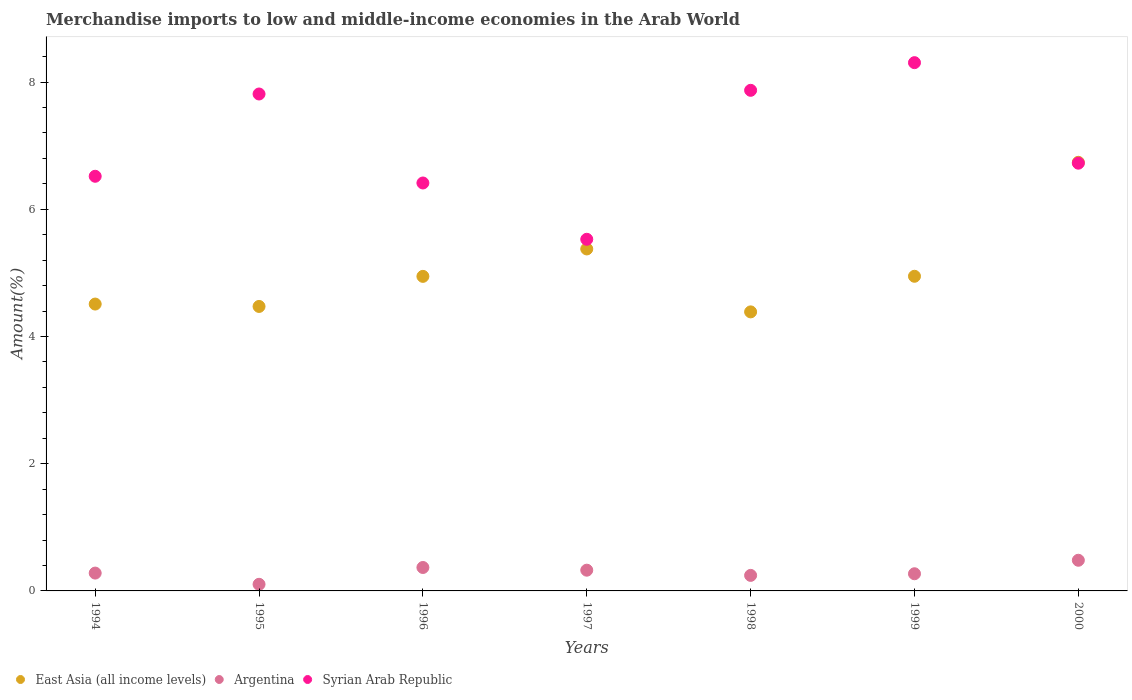How many different coloured dotlines are there?
Your response must be concise. 3. What is the percentage of amount earned from merchandise imports in East Asia (all income levels) in 1995?
Provide a short and direct response. 4.47. Across all years, what is the maximum percentage of amount earned from merchandise imports in East Asia (all income levels)?
Your response must be concise. 6.74. Across all years, what is the minimum percentage of amount earned from merchandise imports in Syrian Arab Republic?
Your response must be concise. 5.53. In which year was the percentage of amount earned from merchandise imports in East Asia (all income levels) maximum?
Provide a short and direct response. 2000. What is the total percentage of amount earned from merchandise imports in Syrian Arab Republic in the graph?
Ensure brevity in your answer.  49.17. What is the difference between the percentage of amount earned from merchandise imports in East Asia (all income levels) in 1997 and that in 2000?
Offer a very short reply. -1.36. What is the difference between the percentage of amount earned from merchandise imports in East Asia (all income levels) in 1995 and the percentage of amount earned from merchandise imports in Syrian Arab Republic in 1999?
Ensure brevity in your answer.  -3.83. What is the average percentage of amount earned from merchandise imports in Argentina per year?
Make the answer very short. 0.3. In the year 1994, what is the difference between the percentage of amount earned from merchandise imports in East Asia (all income levels) and percentage of amount earned from merchandise imports in Syrian Arab Republic?
Provide a succinct answer. -2.01. In how many years, is the percentage of amount earned from merchandise imports in Syrian Arab Republic greater than 2.4 %?
Keep it short and to the point. 7. What is the ratio of the percentage of amount earned from merchandise imports in Argentina in 1995 to that in 2000?
Your answer should be compact. 0.22. What is the difference between the highest and the second highest percentage of amount earned from merchandise imports in East Asia (all income levels)?
Your answer should be compact. 1.36. What is the difference between the highest and the lowest percentage of amount earned from merchandise imports in Syrian Arab Republic?
Your response must be concise. 2.78. In how many years, is the percentage of amount earned from merchandise imports in Syrian Arab Republic greater than the average percentage of amount earned from merchandise imports in Syrian Arab Republic taken over all years?
Give a very brief answer. 3. Is it the case that in every year, the sum of the percentage of amount earned from merchandise imports in East Asia (all income levels) and percentage of amount earned from merchandise imports in Syrian Arab Republic  is greater than the percentage of amount earned from merchandise imports in Argentina?
Make the answer very short. Yes. Does the percentage of amount earned from merchandise imports in Syrian Arab Republic monotonically increase over the years?
Your answer should be compact. No. Is the percentage of amount earned from merchandise imports in Argentina strictly greater than the percentage of amount earned from merchandise imports in East Asia (all income levels) over the years?
Your answer should be very brief. No. How many years are there in the graph?
Keep it short and to the point. 7. What is the difference between two consecutive major ticks on the Y-axis?
Offer a very short reply. 2. Are the values on the major ticks of Y-axis written in scientific E-notation?
Ensure brevity in your answer.  No. Does the graph contain grids?
Provide a succinct answer. No. Where does the legend appear in the graph?
Your response must be concise. Bottom left. How many legend labels are there?
Ensure brevity in your answer.  3. What is the title of the graph?
Provide a succinct answer. Merchandise imports to low and middle-income economies in the Arab World. Does "Estonia" appear as one of the legend labels in the graph?
Provide a short and direct response. No. What is the label or title of the Y-axis?
Offer a terse response. Amount(%). What is the Amount(%) of East Asia (all income levels) in 1994?
Ensure brevity in your answer.  4.51. What is the Amount(%) in Argentina in 1994?
Ensure brevity in your answer.  0.28. What is the Amount(%) in Syrian Arab Republic in 1994?
Provide a short and direct response. 6.52. What is the Amount(%) in East Asia (all income levels) in 1995?
Provide a succinct answer. 4.47. What is the Amount(%) of Argentina in 1995?
Ensure brevity in your answer.  0.1. What is the Amount(%) in Syrian Arab Republic in 1995?
Your answer should be compact. 7.81. What is the Amount(%) of East Asia (all income levels) in 1996?
Your answer should be compact. 4.95. What is the Amount(%) in Argentina in 1996?
Provide a short and direct response. 0.37. What is the Amount(%) in Syrian Arab Republic in 1996?
Provide a short and direct response. 6.41. What is the Amount(%) in East Asia (all income levels) in 1997?
Give a very brief answer. 5.38. What is the Amount(%) in Argentina in 1997?
Ensure brevity in your answer.  0.33. What is the Amount(%) of Syrian Arab Republic in 1997?
Keep it short and to the point. 5.53. What is the Amount(%) in East Asia (all income levels) in 1998?
Your answer should be compact. 4.39. What is the Amount(%) in Argentina in 1998?
Make the answer very short. 0.24. What is the Amount(%) in Syrian Arab Republic in 1998?
Your answer should be very brief. 7.87. What is the Amount(%) of East Asia (all income levels) in 1999?
Provide a succinct answer. 4.95. What is the Amount(%) in Argentina in 1999?
Give a very brief answer. 0.27. What is the Amount(%) of Syrian Arab Republic in 1999?
Your answer should be very brief. 8.3. What is the Amount(%) in East Asia (all income levels) in 2000?
Offer a very short reply. 6.74. What is the Amount(%) in Argentina in 2000?
Provide a short and direct response. 0.48. What is the Amount(%) in Syrian Arab Republic in 2000?
Provide a succinct answer. 6.72. Across all years, what is the maximum Amount(%) of East Asia (all income levels)?
Offer a very short reply. 6.74. Across all years, what is the maximum Amount(%) of Argentina?
Your answer should be compact. 0.48. Across all years, what is the maximum Amount(%) of Syrian Arab Republic?
Keep it short and to the point. 8.3. Across all years, what is the minimum Amount(%) in East Asia (all income levels)?
Provide a short and direct response. 4.39. Across all years, what is the minimum Amount(%) of Argentina?
Offer a very short reply. 0.1. Across all years, what is the minimum Amount(%) of Syrian Arab Republic?
Make the answer very short. 5.53. What is the total Amount(%) in East Asia (all income levels) in the graph?
Your answer should be compact. 35.37. What is the total Amount(%) in Argentina in the graph?
Offer a very short reply. 2.07. What is the total Amount(%) of Syrian Arab Republic in the graph?
Keep it short and to the point. 49.17. What is the difference between the Amount(%) in East Asia (all income levels) in 1994 and that in 1995?
Your answer should be very brief. 0.04. What is the difference between the Amount(%) in Argentina in 1994 and that in 1995?
Your response must be concise. 0.18. What is the difference between the Amount(%) of Syrian Arab Republic in 1994 and that in 1995?
Your response must be concise. -1.29. What is the difference between the Amount(%) in East Asia (all income levels) in 1994 and that in 1996?
Offer a very short reply. -0.44. What is the difference between the Amount(%) of Argentina in 1994 and that in 1996?
Provide a succinct answer. -0.09. What is the difference between the Amount(%) of Syrian Arab Republic in 1994 and that in 1996?
Give a very brief answer. 0.11. What is the difference between the Amount(%) in East Asia (all income levels) in 1994 and that in 1997?
Your answer should be very brief. -0.87. What is the difference between the Amount(%) in Argentina in 1994 and that in 1997?
Your response must be concise. -0.05. What is the difference between the Amount(%) of Syrian Arab Republic in 1994 and that in 1997?
Offer a very short reply. 0.99. What is the difference between the Amount(%) in East Asia (all income levels) in 1994 and that in 1998?
Give a very brief answer. 0.12. What is the difference between the Amount(%) in Argentina in 1994 and that in 1998?
Provide a short and direct response. 0.04. What is the difference between the Amount(%) of Syrian Arab Republic in 1994 and that in 1998?
Provide a succinct answer. -1.35. What is the difference between the Amount(%) in East Asia (all income levels) in 1994 and that in 1999?
Offer a very short reply. -0.44. What is the difference between the Amount(%) in Argentina in 1994 and that in 1999?
Provide a short and direct response. 0.01. What is the difference between the Amount(%) of Syrian Arab Republic in 1994 and that in 1999?
Offer a very short reply. -1.79. What is the difference between the Amount(%) of East Asia (all income levels) in 1994 and that in 2000?
Ensure brevity in your answer.  -2.23. What is the difference between the Amount(%) of Argentina in 1994 and that in 2000?
Provide a short and direct response. -0.2. What is the difference between the Amount(%) in Syrian Arab Republic in 1994 and that in 2000?
Give a very brief answer. -0.21. What is the difference between the Amount(%) in East Asia (all income levels) in 1995 and that in 1996?
Provide a short and direct response. -0.47. What is the difference between the Amount(%) of Argentina in 1995 and that in 1996?
Provide a short and direct response. -0.26. What is the difference between the Amount(%) in Syrian Arab Republic in 1995 and that in 1996?
Your response must be concise. 1.4. What is the difference between the Amount(%) of East Asia (all income levels) in 1995 and that in 1997?
Offer a terse response. -0.9. What is the difference between the Amount(%) in Argentina in 1995 and that in 1997?
Provide a short and direct response. -0.22. What is the difference between the Amount(%) of Syrian Arab Republic in 1995 and that in 1997?
Offer a terse response. 2.28. What is the difference between the Amount(%) in East Asia (all income levels) in 1995 and that in 1998?
Provide a succinct answer. 0.09. What is the difference between the Amount(%) in Argentina in 1995 and that in 1998?
Provide a short and direct response. -0.14. What is the difference between the Amount(%) of Syrian Arab Republic in 1995 and that in 1998?
Offer a very short reply. -0.06. What is the difference between the Amount(%) of East Asia (all income levels) in 1995 and that in 1999?
Offer a terse response. -0.47. What is the difference between the Amount(%) of Argentina in 1995 and that in 1999?
Provide a short and direct response. -0.17. What is the difference between the Amount(%) of Syrian Arab Republic in 1995 and that in 1999?
Make the answer very short. -0.49. What is the difference between the Amount(%) in East Asia (all income levels) in 1995 and that in 2000?
Offer a terse response. -2.27. What is the difference between the Amount(%) in Argentina in 1995 and that in 2000?
Provide a short and direct response. -0.38. What is the difference between the Amount(%) in Syrian Arab Republic in 1995 and that in 2000?
Make the answer very short. 1.09. What is the difference between the Amount(%) in East Asia (all income levels) in 1996 and that in 1997?
Make the answer very short. -0.43. What is the difference between the Amount(%) of Argentina in 1996 and that in 1997?
Provide a short and direct response. 0.04. What is the difference between the Amount(%) in Syrian Arab Republic in 1996 and that in 1997?
Keep it short and to the point. 0.89. What is the difference between the Amount(%) of East Asia (all income levels) in 1996 and that in 1998?
Make the answer very short. 0.56. What is the difference between the Amount(%) of Argentina in 1996 and that in 1998?
Keep it short and to the point. 0.12. What is the difference between the Amount(%) in Syrian Arab Republic in 1996 and that in 1998?
Provide a succinct answer. -1.46. What is the difference between the Amount(%) in East Asia (all income levels) in 1996 and that in 1999?
Make the answer very short. -0. What is the difference between the Amount(%) in Argentina in 1996 and that in 1999?
Offer a terse response. 0.1. What is the difference between the Amount(%) of Syrian Arab Republic in 1996 and that in 1999?
Your answer should be compact. -1.89. What is the difference between the Amount(%) of East Asia (all income levels) in 1996 and that in 2000?
Keep it short and to the point. -1.79. What is the difference between the Amount(%) in Argentina in 1996 and that in 2000?
Keep it short and to the point. -0.11. What is the difference between the Amount(%) in Syrian Arab Republic in 1996 and that in 2000?
Your answer should be compact. -0.31. What is the difference between the Amount(%) of Argentina in 1997 and that in 1998?
Make the answer very short. 0.08. What is the difference between the Amount(%) of Syrian Arab Republic in 1997 and that in 1998?
Offer a terse response. -2.34. What is the difference between the Amount(%) in East Asia (all income levels) in 1997 and that in 1999?
Keep it short and to the point. 0.43. What is the difference between the Amount(%) in Argentina in 1997 and that in 1999?
Ensure brevity in your answer.  0.06. What is the difference between the Amount(%) in Syrian Arab Republic in 1997 and that in 1999?
Offer a very short reply. -2.78. What is the difference between the Amount(%) in East Asia (all income levels) in 1997 and that in 2000?
Make the answer very short. -1.36. What is the difference between the Amount(%) in Argentina in 1997 and that in 2000?
Your answer should be compact. -0.16. What is the difference between the Amount(%) in Syrian Arab Republic in 1997 and that in 2000?
Offer a terse response. -1.2. What is the difference between the Amount(%) in East Asia (all income levels) in 1998 and that in 1999?
Provide a succinct answer. -0.56. What is the difference between the Amount(%) of Argentina in 1998 and that in 1999?
Offer a terse response. -0.03. What is the difference between the Amount(%) of Syrian Arab Republic in 1998 and that in 1999?
Provide a short and direct response. -0.43. What is the difference between the Amount(%) of East Asia (all income levels) in 1998 and that in 2000?
Keep it short and to the point. -2.35. What is the difference between the Amount(%) of Argentina in 1998 and that in 2000?
Keep it short and to the point. -0.24. What is the difference between the Amount(%) of Syrian Arab Republic in 1998 and that in 2000?
Your answer should be very brief. 1.15. What is the difference between the Amount(%) of East Asia (all income levels) in 1999 and that in 2000?
Your response must be concise. -1.79. What is the difference between the Amount(%) of Argentina in 1999 and that in 2000?
Offer a terse response. -0.21. What is the difference between the Amount(%) of Syrian Arab Republic in 1999 and that in 2000?
Keep it short and to the point. 1.58. What is the difference between the Amount(%) of East Asia (all income levels) in 1994 and the Amount(%) of Argentina in 1995?
Give a very brief answer. 4.41. What is the difference between the Amount(%) of East Asia (all income levels) in 1994 and the Amount(%) of Syrian Arab Republic in 1995?
Offer a terse response. -3.3. What is the difference between the Amount(%) of Argentina in 1994 and the Amount(%) of Syrian Arab Republic in 1995?
Your response must be concise. -7.53. What is the difference between the Amount(%) of East Asia (all income levels) in 1994 and the Amount(%) of Argentina in 1996?
Your answer should be very brief. 4.14. What is the difference between the Amount(%) of East Asia (all income levels) in 1994 and the Amount(%) of Syrian Arab Republic in 1996?
Give a very brief answer. -1.9. What is the difference between the Amount(%) in Argentina in 1994 and the Amount(%) in Syrian Arab Republic in 1996?
Your answer should be compact. -6.13. What is the difference between the Amount(%) in East Asia (all income levels) in 1994 and the Amount(%) in Argentina in 1997?
Give a very brief answer. 4.18. What is the difference between the Amount(%) in East Asia (all income levels) in 1994 and the Amount(%) in Syrian Arab Republic in 1997?
Your answer should be very brief. -1.02. What is the difference between the Amount(%) in Argentina in 1994 and the Amount(%) in Syrian Arab Republic in 1997?
Offer a terse response. -5.25. What is the difference between the Amount(%) of East Asia (all income levels) in 1994 and the Amount(%) of Argentina in 1998?
Offer a very short reply. 4.27. What is the difference between the Amount(%) of East Asia (all income levels) in 1994 and the Amount(%) of Syrian Arab Republic in 1998?
Offer a very short reply. -3.36. What is the difference between the Amount(%) of Argentina in 1994 and the Amount(%) of Syrian Arab Republic in 1998?
Keep it short and to the point. -7.59. What is the difference between the Amount(%) of East Asia (all income levels) in 1994 and the Amount(%) of Argentina in 1999?
Give a very brief answer. 4.24. What is the difference between the Amount(%) in East Asia (all income levels) in 1994 and the Amount(%) in Syrian Arab Republic in 1999?
Your response must be concise. -3.79. What is the difference between the Amount(%) of Argentina in 1994 and the Amount(%) of Syrian Arab Republic in 1999?
Provide a short and direct response. -8.02. What is the difference between the Amount(%) in East Asia (all income levels) in 1994 and the Amount(%) in Argentina in 2000?
Give a very brief answer. 4.03. What is the difference between the Amount(%) of East Asia (all income levels) in 1994 and the Amount(%) of Syrian Arab Republic in 2000?
Your response must be concise. -2.21. What is the difference between the Amount(%) in Argentina in 1994 and the Amount(%) in Syrian Arab Republic in 2000?
Your response must be concise. -6.44. What is the difference between the Amount(%) of East Asia (all income levels) in 1995 and the Amount(%) of Argentina in 1996?
Offer a terse response. 4.1. What is the difference between the Amount(%) in East Asia (all income levels) in 1995 and the Amount(%) in Syrian Arab Republic in 1996?
Give a very brief answer. -1.94. What is the difference between the Amount(%) in Argentina in 1995 and the Amount(%) in Syrian Arab Republic in 1996?
Keep it short and to the point. -6.31. What is the difference between the Amount(%) of East Asia (all income levels) in 1995 and the Amount(%) of Argentina in 1997?
Your answer should be very brief. 4.15. What is the difference between the Amount(%) of East Asia (all income levels) in 1995 and the Amount(%) of Syrian Arab Republic in 1997?
Give a very brief answer. -1.06. What is the difference between the Amount(%) of Argentina in 1995 and the Amount(%) of Syrian Arab Republic in 1997?
Ensure brevity in your answer.  -5.42. What is the difference between the Amount(%) of East Asia (all income levels) in 1995 and the Amount(%) of Argentina in 1998?
Your answer should be compact. 4.23. What is the difference between the Amount(%) of East Asia (all income levels) in 1995 and the Amount(%) of Syrian Arab Republic in 1998?
Your answer should be very brief. -3.4. What is the difference between the Amount(%) in Argentina in 1995 and the Amount(%) in Syrian Arab Republic in 1998?
Your response must be concise. -7.77. What is the difference between the Amount(%) in East Asia (all income levels) in 1995 and the Amount(%) in Argentina in 1999?
Your response must be concise. 4.2. What is the difference between the Amount(%) in East Asia (all income levels) in 1995 and the Amount(%) in Syrian Arab Republic in 1999?
Keep it short and to the point. -3.83. What is the difference between the Amount(%) of Argentina in 1995 and the Amount(%) of Syrian Arab Republic in 1999?
Offer a very short reply. -8.2. What is the difference between the Amount(%) in East Asia (all income levels) in 1995 and the Amount(%) in Argentina in 2000?
Your response must be concise. 3.99. What is the difference between the Amount(%) in East Asia (all income levels) in 1995 and the Amount(%) in Syrian Arab Republic in 2000?
Ensure brevity in your answer.  -2.25. What is the difference between the Amount(%) of Argentina in 1995 and the Amount(%) of Syrian Arab Republic in 2000?
Your answer should be compact. -6.62. What is the difference between the Amount(%) in East Asia (all income levels) in 1996 and the Amount(%) in Argentina in 1997?
Your answer should be compact. 4.62. What is the difference between the Amount(%) of East Asia (all income levels) in 1996 and the Amount(%) of Syrian Arab Republic in 1997?
Make the answer very short. -0.58. What is the difference between the Amount(%) in Argentina in 1996 and the Amount(%) in Syrian Arab Republic in 1997?
Your answer should be compact. -5.16. What is the difference between the Amount(%) in East Asia (all income levels) in 1996 and the Amount(%) in Argentina in 1998?
Offer a terse response. 4.7. What is the difference between the Amount(%) in East Asia (all income levels) in 1996 and the Amount(%) in Syrian Arab Republic in 1998?
Give a very brief answer. -2.92. What is the difference between the Amount(%) in Argentina in 1996 and the Amount(%) in Syrian Arab Republic in 1998?
Provide a succinct answer. -7.5. What is the difference between the Amount(%) in East Asia (all income levels) in 1996 and the Amount(%) in Argentina in 1999?
Offer a very short reply. 4.68. What is the difference between the Amount(%) in East Asia (all income levels) in 1996 and the Amount(%) in Syrian Arab Republic in 1999?
Offer a terse response. -3.36. What is the difference between the Amount(%) in Argentina in 1996 and the Amount(%) in Syrian Arab Republic in 1999?
Make the answer very short. -7.94. What is the difference between the Amount(%) in East Asia (all income levels) in 1996 and the Amount(%) in Argentina in 2000?
Offer a very short reply. 4.46. What is the difference between the Amount(%) of East Asia (all income levels) in 1996 and the Amount(%) of Syrian Arab Republic in 2000?
Keep it short and to the point. -1.78. What is the difference between the Amount(%) of Argentina in 1996 and the Amount(%) of Syrian Arab Republic in 2000?
Offer a terse response. -6.36. What is the difference between the Amount(%) in East Asia (all income levels) in 1997 and the Amount(%) in Argentina in 1998?
Keep it short and to the point. 5.13. What is the difference between the Amount(%) in East Asia (all income levels) in 1997 and the Amount(%) in Syrian Arab Republic in 1998?
Ensure brevity in your answer.  -2.49. What is the difference between the Amount(%) of Argentina in 1997 and the Amount(%) of Syrian Arab Republic in 1998?
Offer a very short reply. -7.54. What is the difference between the Amount(%) in East Asia (all income levels) in 1997 and the Amount(%) in Argentina in 1999?
Provide a short and direct response. 5.11. What is the difference between the Amount(%) of East Asia (all income levels) in 1997 and the Amount(%) of Syrian Arab Republic in 1999?
Ensure brevity in your answer.  -2.93. What is the difference between the Amount(%) of Argentina in 1997 and the Amount(%) of Syrian Arab Republic in 1999?
Make the answer very short. -7.98. What is the difference between the Amount(%) of East Asia (all income levels) in 1997 and the Amount(%) of Argentina in 2000?
Offer a terse response. 4.89. What is the difference between the Amount(%) in East Asia (all income levels) in 1997 and the Amount(%) in Syrian Arab Republic in 2000?
Make the answer very short. -1.35. What is the difference between the Amount(%) of Argentina in 1997 and the Amount(%) of Syrian Arab Republic in 2000?
Give a very brief answer. -6.4. What is the difference between the Amount(%) of East Asia (all income levels) in 1998 and the Amount(%) of Argentina in 1999?
Your answer should be very brief. 4.12. What is the difference between the Amount(%) in East Asia (all income levels) in 1998 and the Amount(%) in Syrian Arab Republic in 1999?
Your response must be concise. -3.92. What is the difference between the Amount(%) in Argentina in 1998 and the Amount(%) in Syrian Arab Republic in 1999?
Provide a succinct answer. -8.06. What is the difference between the Amount(%) in East Asia (all income levels) in 1998 and the Amount(%) in Argentina in 2000?
Keep it short and to the point. 3.9. What is the difference between the Amount(%) in East Asia (all income levels) in 1998 and the Amount(%) in Syrian Arab Republic in 2000?
Offer a terse response. -2.34. What is the difference between the Amount(%) in Argentina in 1998 and the Amount(%) in Syrian Arab Republic in 2000?
Your response must be concise. -6.48. What is the difference between the Amount(%) in East Asia (all income levels) in 1999 and the Amount(%) in Argentina in 2000?
Your answer should be very brief. 4.46. What is the difference between the Amount(%) of East Asia (all income levels) in 1999 and the Amount(%) of Syrian Arab Republic in 2000?
Keep it short and to the point. -1.78. What is the difference between the Amount(%) of Argentina in 1999 and the Amount(%) of Syrian Arab Republic in 2000?
Make the answer very short. -6.45. What is the average Amount(%) of East Asia (all income levels) per year?
Make the answer very short. 5.05. What is the average Amount(%) in Argentina per year?
Ensure brevity in your answer.  0.3. What is the average Amount(%) in Syrian Arab Republic per year?
Make the answer very short. 7.02. In the year 1994, what is the difference between the Amount(%) of East Asia (all income levels) and Amount(%) of Argentina?
Offer a very short reply. 4.23. In the year 1994, what is the difference between the Amount(%) in East Asia (all income levels) and Amount(%) in Syrian Arab Republic?
Keep it short and to the point. -2.01. In the year 1994, what is the difference between the Amount(%) of Argentina and Amount(%) of Syrian Arab Republic?
Give a very brief answer. -6.24. In the year 1995, what is the difference between the Amount(%) in East Asia (all income levels) and Amount(%) in Argentina?
Your response must be concise. 4.37. In the year 1995, what is the difference between the Amount(%) of East Asia (all income levels) and Amount(%) of Syrian Arab Republic?
Offer a terse response. -3.34. In the year 1995, what is the difference between the Amount(%) in Argentina and Amount(%) in Syrian Arab Republic?
Provide a short and direct response. -7.71. In the year 1996, what is the difference between the Amount(%) of East Asia (all income levels) and Amount(%) of Argentina?
Provide a succinct answer. 4.58. In the year 1996, what is the difference between the Amount(%) in East Asia (all income levels) and Amount(%) in Syrian Arab Republic?
Give a very brief answer. -1.47. In the year 1996, what is the difference between the Amount(%) of Argentina and Amount(%) of Syrian Arab Republic?
Your response must be concise. -6.04. In the year 1997, what is the difference between the Amount(%) in East Asia (all income levels) and Amount(%) in Argentina?
Your response must be concise. 5.05. In the year 1997, what is the difference between the Amount(%) in East Asia (all income levels) and Amount(%) in Syrian Arab Republic?
Provide a succinct answer. -0.15. In the year 1997, what is the difference between the Amount(%) of Argentina and Amount(%) of Syrian Arab Republic?
Provide a short and direct response. -5.2. In the year 1998, what is the difference between the Amount(%) in East Asia (all income levels) and Amount(%) in Argentina?
Offer a very short reply. 4.14. In the year 1998, what is the difference between the Amount(%) of East Asia (all income levels) and Amount(%) of Syrian Arab Republic?
Your answer should be very brief. -3.48. In the year 1998, what is the difference between the Amount(%) in Argentina and Amount(%) in Syrian Arab Republic?
Your response must be concise. -7.63. In the year 1999, what is the difference between the Amount(%) in East Asia (all income levels) and Amount(%) in Argentina?
Keep it short and to the point. 4.68. In the year 1999, what is the difference between the Amount(%) in East Asia (all income levels) and Amount(%) in Syrian Arab Republic?
Ensure brevity in your answer.  -3.36. In the year 1999, what is the difference between the Amount(%) in Argentina and Amount(%) in Syrian Arab Republic?
Ensure brevity in your answer.  -8.03. In the year 2000, what is the difference between the Amount(%) of East Asia (all income levels) and Amount(%) of Argentina?
Provide a short and direct response. 6.26. In the year 2000, what is the difference between the Amount(%) of East Asia (all income levels) and Amount(%) of Syrian Arab Republic?
Offer a very short reply. 0.01. In the year 2000, what is the difference between the Amount(%) of Argentina and Amount(%) of Syrian Arab Republic?
Give a very brief answer. -6.24. What is the ratio of the Amount(%) in East Asia (all income levels) in 1994 to that in 1995?
Give a very brief answer. 1.01. What is the ratio of the Amount(%) in Argentina in 1994 to that in 1995?
Make the answer very short. 2.69. What is the ratio of the Amount(%) in Syrian Arab Republic in 1994 to that in 1995?
Make the answer very short. 0.83. What is the ratio of the Amount(%) in East Asia (all income levels) in 1994 to that in 1996?
Your answer should be compact. 0.91. What is the ratio of the Amount(%) in Argentina in 1994 to that in 1996?
Provide a short and direct response. 0.76. What is the ratio of the Amount(%) in Syrian Arab Republic in 1994 to that in 1996?
Provide a succinct answer. 1.02. What is the ratio of the Amount(%) of East Asia (all income levels) in 1994 to that in 1997?
Offer a very short reply. 0.84. What is the ratio of the Amount(%) in Argentina in 1994 to that in 1997?
Ensure brevity in your answer.  0.86. What is the ratio of the Amount(%) in Syrian Arab Republic in 1994 to that in 1997?
Your answer should be compact. 1.18. What is the ratio of the Amount(%) of East Asia (all income levels) in 1994 to that in 1998?
Your answer should be compact. 1.03. What is the ratio of the Amount(%) of Argentina in 1994 to that in 1998?
Keep it short and to the point. 1.15. What is the ratio of the Amount(%) in Syrian Arab Republic in 1994 to that in 1998?
Make the answer very short. 0.83. What is the ratio of the Amount(%) of East Asia (all income levels) in 1994 to that in 1999?
Your response must be concise. 0.91. What is the ratio of the Amount(%) of Argentina in 1994 to that in 1999?
Offer a very short reply. 1.04. What is the ratio of the Amount(%) of Syrian Arab Republic in 1994 to that in 1999?
Offer a very short reply. 0.78. What is the ratio of the Amount(%) in East Asia (all income levels) in 1994 to that in 2000?
Keep it short and to the point. 0.67. What is the ratio of the Amount(%) of Argentina in 1994 to that in 2000?
Your response must be concise. 0.58. What is the ratio of the Amount(%) in Syrian Arab Republic in 1994 to that in 2000?
Keep it short and to the point. 0.97. What is the ratio of the Amount(%) of East Asia (all income levels) in 1995 to that in 1996?
Make the answer very short. 0.9. What is the ratio of the Amount(%) of Argentina in 1995 to that in 1996?
Your answer should be very brief. 0.28. What is the ratio of the Amount(%) of Syrian Arab Republic in 1995 to that in 1996?
Ensure brevity in your answer.  1.22. What is the ratio of the Amount(%) in East Asia (all income levels) in 1995 to that in 1997?
Your response must be concise. 0.83. What is the ratio of the Amount(%) in Argentina in 1995 to that in 1997?
Your response must be concise. 0.32. What is the ratio of the Amount(%) of Syrian Arab Republic in 1995 to that in 1997?
Ensure brevity in your answer.  1.41. What is the ratio of the Amount(%) of East Asia (all income levels) in 1995 to that in 1998?
Provide a short and direct response. 1.02. What is the ratio of the Amount(%) in Argentina in 1995 to that in 1998?
Keep it short and to the point. 0.43. What is the ratio of the Amount(%) in Syrian Arab Republic in 1995 to that in 1998?
Provide a succinct answer. 0.99. What is the ratio of the Amount(%) of East Asia (all income levels) in 1995 to that in 1999?
Your answer should be very brief. 0.9. What is the ratio of the Amount(%) of Argentina in 1995 to that in 1999?
Offer a very short reply. 0.39. What is the ratio of the Amount(%) of Syrian Arab Republic in 1995 to that in 1999?
Provide a short and direct response. 0.94. What is the ratio of the Amount(%) of East Asia (all income levels) in 1995 to that in 2000?
Provide a succinct answer. 0.66. What is the ratio of the Amount(%) in Argentina in 1995 to that in 2000?
Provide a short and direct response. 0.22. What is the ratio of the Amount(%) in Syrian Arab Republic in 1995 to that in 2000?
Make the answer very short. 1.16. What is the ratio of the Amount(%) of East Asia (all income levels) in 1996 to that in 1997?
Provide a short and direct response. 0.92. What is the ratio of the Amount(%) of Argentina in 1996 to that in 1997?
Your response must be concise. 1.13. What is the ratio of the Amount(%) of Syrian Arab Republic in 1996 to that in 1997?
Give a very brief answer. 1.16. What is the ratio of the Amount(%) in East Asia (all income levels) in 1996 to that in 1998?
Your response must be concise. 1.13. What is the ratio of the Amount(%) of Argentina in 1996 to that in 1998?
Give a very brief answer. 1.51. What is the ratio of the Amount(%) in Syrian Arab Republic in 1996 to that in 1998?
Your answer should be compact. 0.81. What is the ratio of the Amount(%) in East Asia (all income levels) in 1996 to that in 1999?
Make the answer very short. 1. What is the ratio of the Amount(%) of Argentina in 1996 to that in 1999?
Keep it short and to the point. 1.37. What is the ratio of the Amount(%) of Syrian Arab Republic in 1996 to that in 1999?
Your answer should be compact. 0.77. What is the ratio of the Amount(%) of East Asia (all income levels) in 1996 to that in 2000?
Ensure brevity in your answer.  0.73. What is the ratio of the Amount(%) of Argentina in 1996 to that in 2000?
Give a very brief answer. 0.76. What is the ratio of the Amount(%) in Syrian Arab Republic in 1996 to that in 2000?
Offer a terse response. 0.95. What is the ratio of the Amount(%) in East Asia (all income levels) in 1997 to that in 1998?
Provide a succinct answer. 1.23. What is the ratio of the Amount(%) in Argentina in 1997 to that in 1998?
Your response must be concise. 1.33. What is the ratio of the Amount(%) of Syrian Arab Republic in 1997 to that in 1998?
Your answer should be very brief. 0.7. What is the ratio of the Amount(%) of East Asia (all income levels) in 1997 to that in 1999?
Your answer should be very brief. 1.09. What is the ratio of the Amount(%) of Argentina in 1997 to that in 1999?
Provide a succinct answer. 1.21. What is the ratio of the Amount(%) in Syrian Arab Republic in 1997 to that in 1999?
Your answer should be very brief. 0.67. What is the ratio of the Amount(%) in East Asia (all income levels) in 1997 to that in 2000?
Your answer should be compact. 0.8. What is the ratio of the Amount(%) in Argentina in 1997 to that in 2000?
Offer a terse response. 0.68. What is the ratio of the Amount(%) in Syrian Arab Republic in 1997 to that in 2000?
Your answer should be compact. 0.82. What is the ratio of the Amount(%) of East Asia (all income levels) in 1998 to that in 1999?
Keep it short and to the point. 0.89. What is the ratio of the Amount(%) in Argentina in 1998 to that in 1999?
Your response must be concise. 0.9. What is the ratio of the Amount(%) in Syrian Arab Republic in 1998 to that in 1999?
Your answer should be very brief. 0.95. What is the ratio of the Amount(%) in East Asia (all income levels) in 1998 to that in 2000?
Ensure brevity in your answer.  0.65. What is the ratio of the Amount(%) in Argentina in 1998 to that in 2000?
Give a very brief answer. 0.51. What is the ratio of the Amount(%) of Syrian Arab Republic in 1998 to that in 2000?
Make the answer very short. 1.17. What is the ratio of the Amount(%) in East Asia (all income levels) in 1999 to that in 2000?
Make the answer very short. 0.73. What is the ratio of the Amount(%) of Argentina in 1999 to that in 2000?
Offer a terse response. 0.56. What is the ratio of the Amount(%) in Syrian Arab Republic in 1999 to that in 2000?
Your answer should be very brief. 1.24. What is the difference between the highest and the second highest Amount(%) in East Asia (all income levels)?
Provide a succinct answer. 1.36. What is the difference between the highest and the second highest Amount(%) in Argentina?
Ensure brevity in your answer.  0.11. What is the difference between the highest and the second highest Amount(%) of Syrian Arab Republic?
Offer a terse response. 0.43. What is the difference between the highest and the lowest Amount(%) in East Asia (all income levels)?
Keep it short and to the point. 2.35. What is the difference between the highest and the lowest Amount(%) of Argentina?
Ensure brevity in your answer.  0.38. What is the difference between the highest and the lowest Amount(%) in Syrian Arab Republic?
Provide a short and direct response. 2.78. 